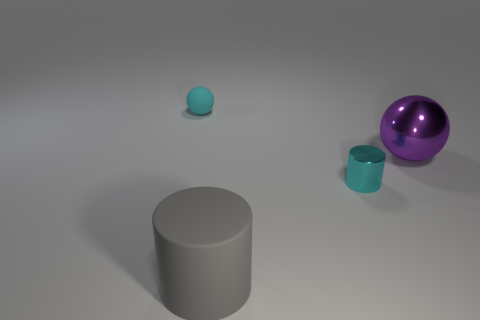What could be the function of these objects if they were in a real-life setting? The cylindrical gray rubber object may serve as a storage container or a base for something to rest upon, while the spherical cyan item could be a decorative piece or a ball, and the purple shiny object appears to look like an ornament or a fancy paperweight. 